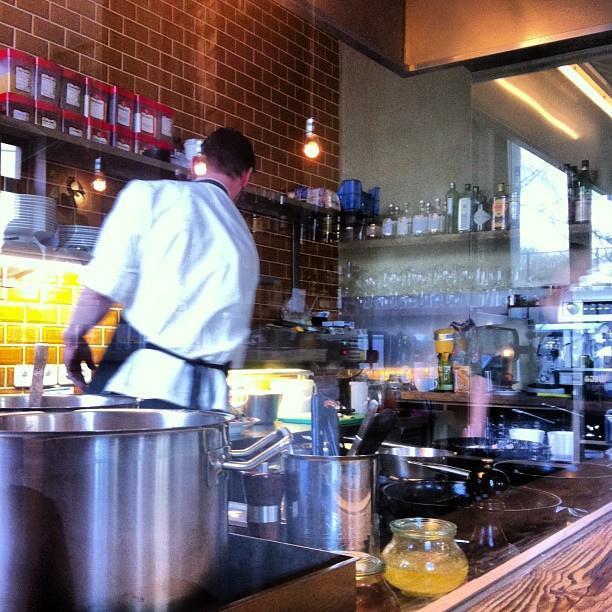How many bottles are in the picture?
Give a very brief answer. 1. How many bowls can you see?
Give a very brief answer. 2. 